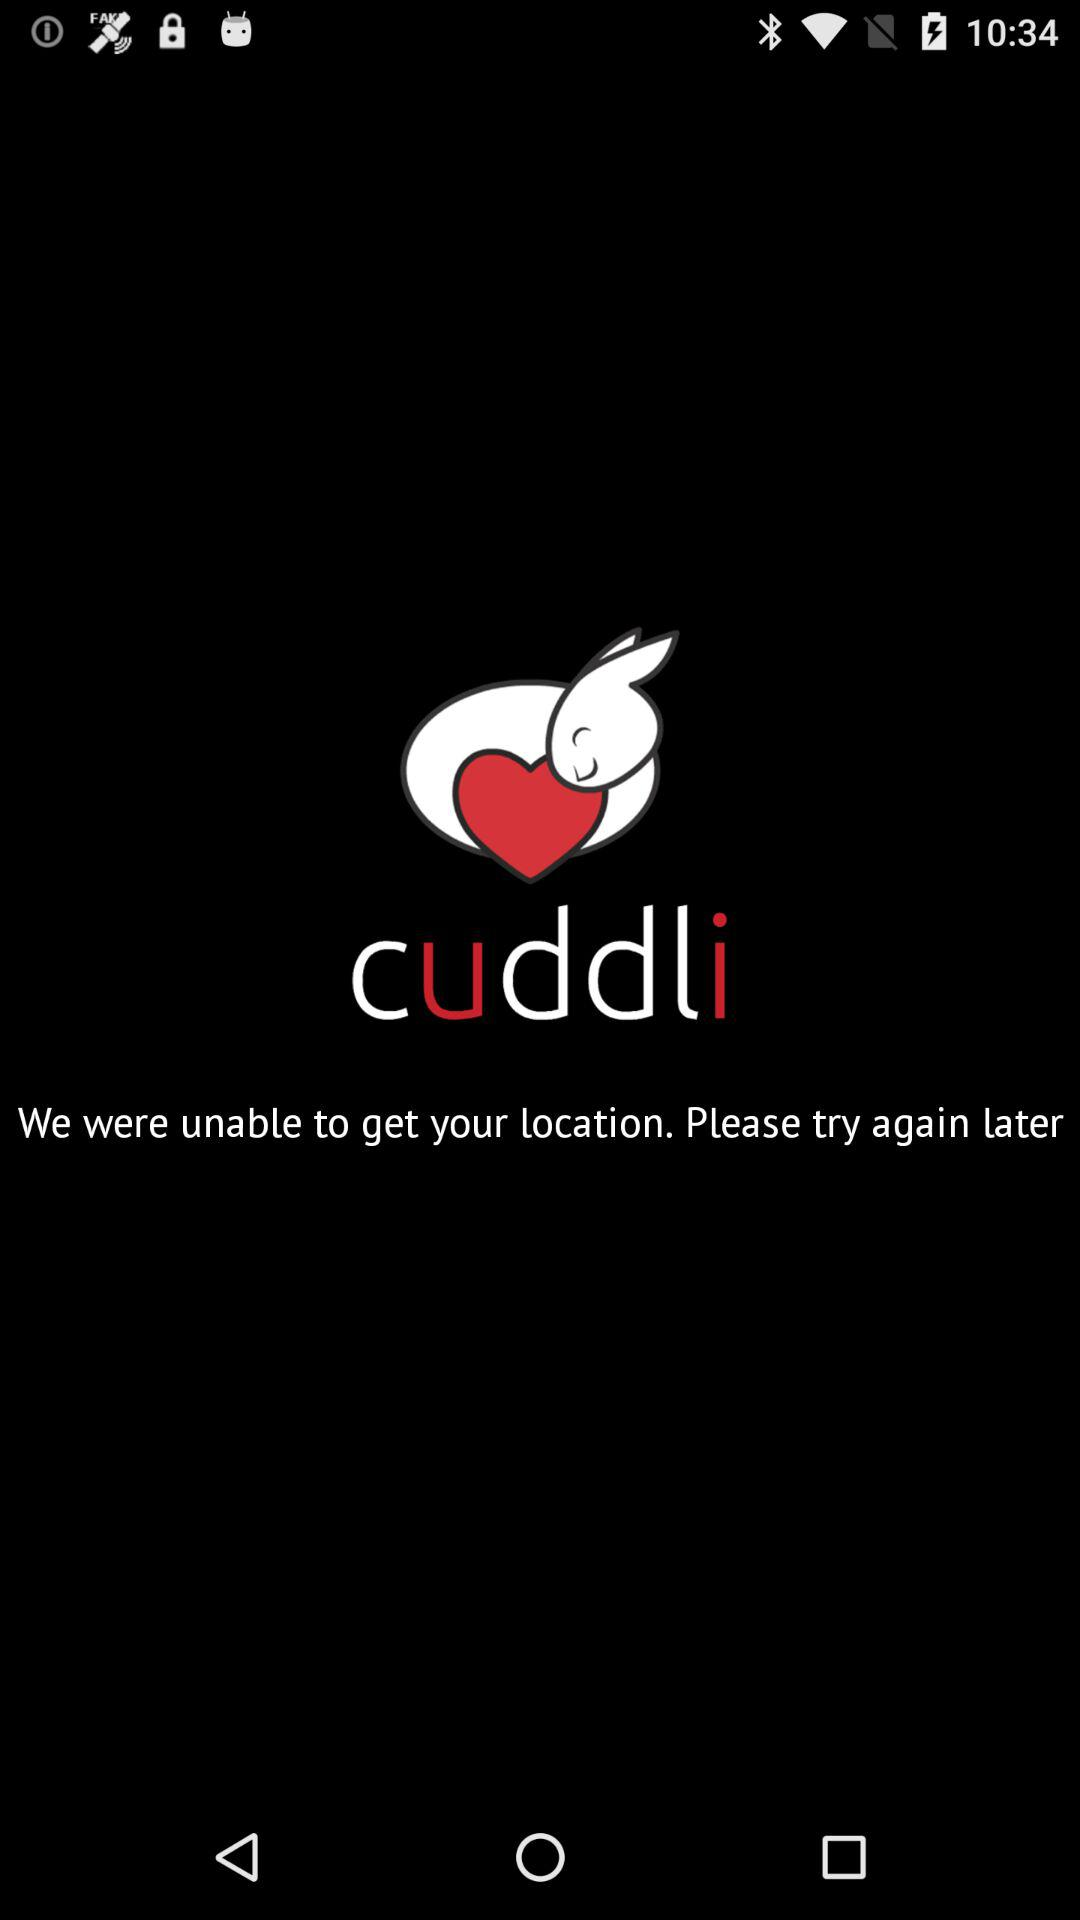What is the application name? The application name is "cuddli". 